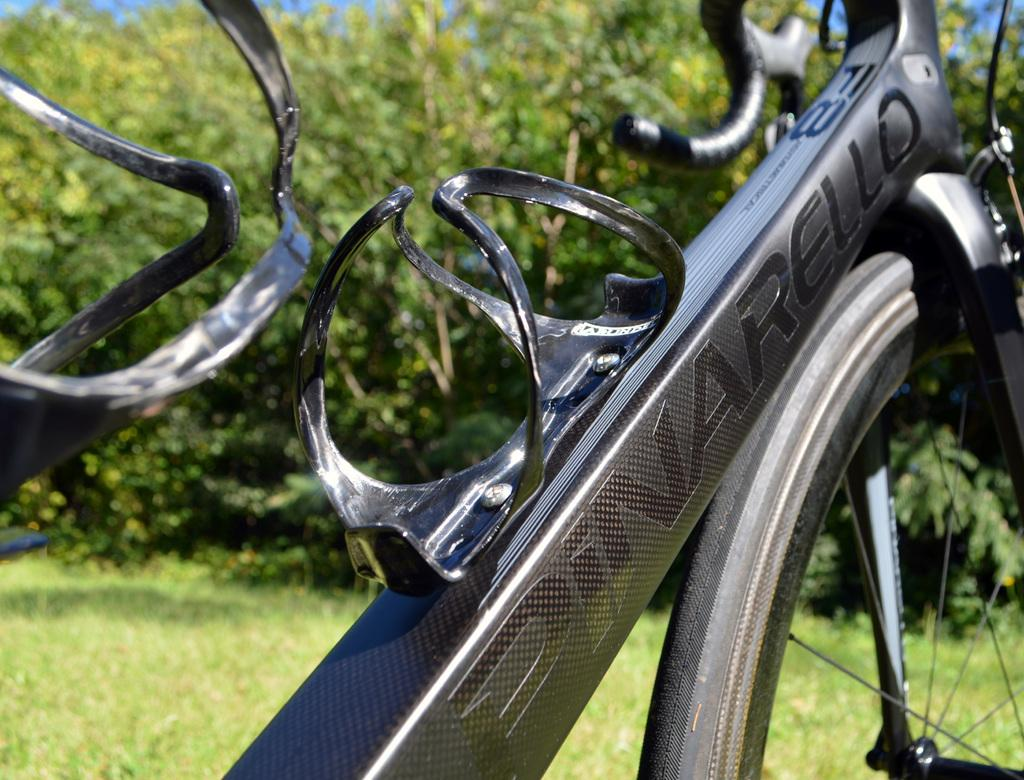What color is the bicycle in the picture? The bicycle in the picture is black. Is there any text or writing on the bicycle? Yes, there is something written on the bicycle. What can be seen in the background of the picture? There are trees and grass in the background of the picture. How would you describe the background of the image? The background of the image is blurred. Can you see a team of people playing with a gun in the image? No, there is no team of people or gun present in the image. The image only features a black color bicycle with writing on it, and a blurred background with trees and grass. 